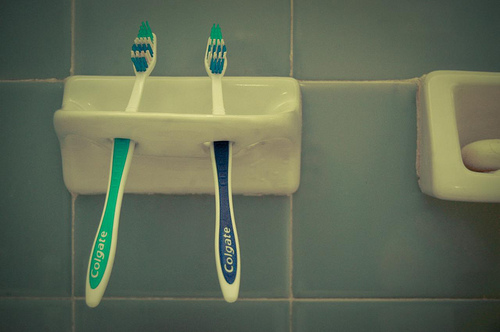Identify the text displayed in this image. Colgate Colgate 